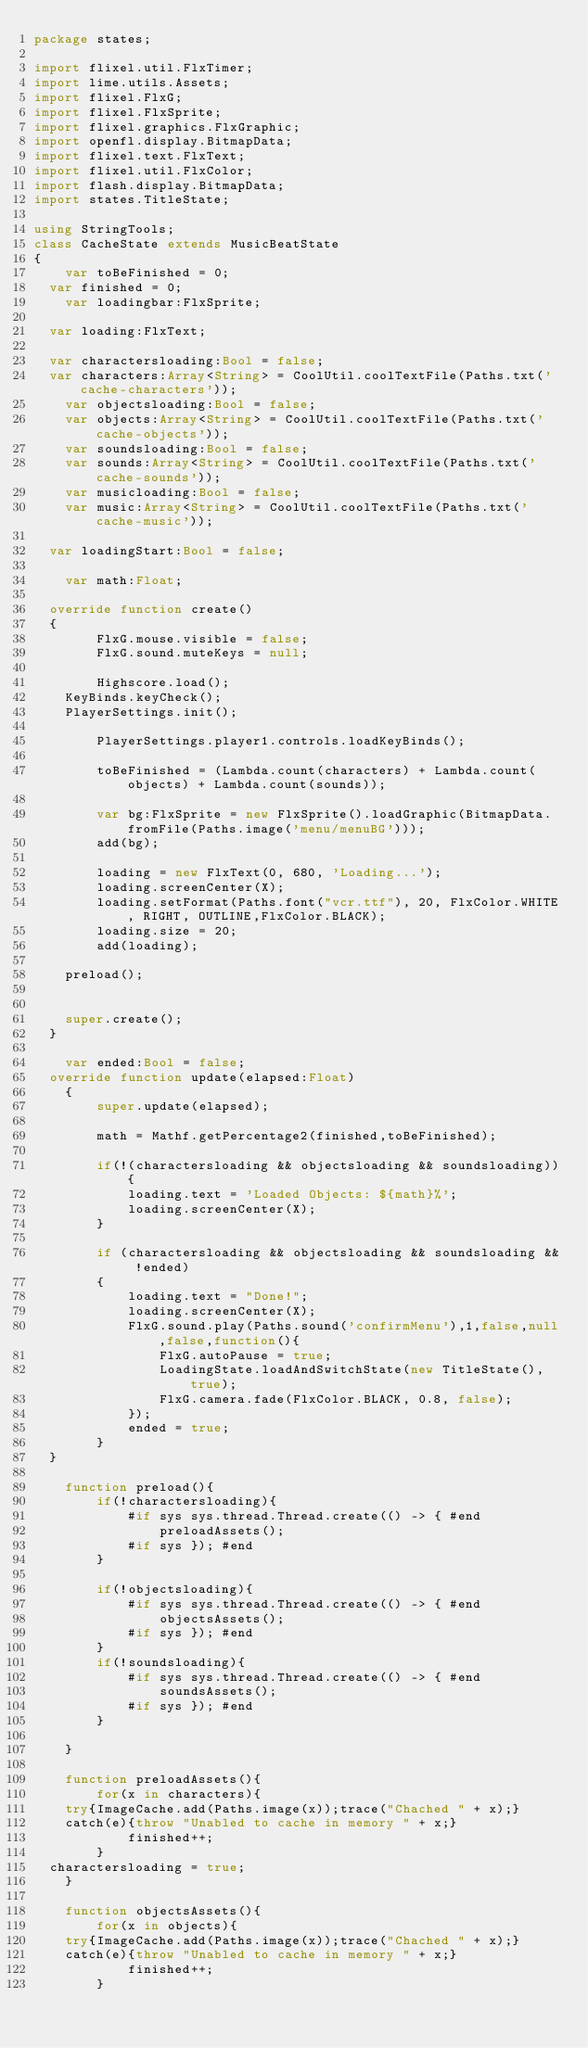<code> <loc_0><loc_0><loc_500><loc_500><_Haxe_>package states;

import flixel.util.FlxTimer;
import lime.utils.Assets;
import flixel.FlxG;
import flixel.FlxSprite;
import flixel.graphics.FlxGraphic;
import openfl.display.BitmapData;
import flixel.text.FlxText;
import flixel.util.FlxColor;
import flash.display.BitmapData;
import states.TitleState;

using StringTools;
class CacheState extends MusicBeatState
{
    var toBeFinished = 0;
	var finished = 0;
    var loadingbar:FlxSprite;

	var loading:FlxText;

	var charactersloading:Bool = false;
	var characters:Array<String> = CoolUtil.coolTextFile(Paths.txt('cache-characters'));
    var objectsloading:Bool = false;
    var objects:Array<String> = CoolUtil.coolTextFile(Paths.txt('cache-objects'));
    var soundsloading:Bool = false;
    var sounds:Array<String> = CoolUtil.coolTextFile(Paths.txt('cache-sounds'));
    var musicloading:Bool = false;
    var music:Array<String> = CoolUtil.coolTextFile(Paths.txt('cache-music'));

	var loadingStart:Bool = false;

    var math:Float;

	override function create()
	{
        FlxG.mouse.visible = false;
        FlxG.sound.muteKeys = null;

        Highscore.load();
		KeyBinds.keyCheck();
		PlayerSettings.init();

        PlayerSettings.player1.controls.loadKeyBinds();

        toBeFinished = (Lambda.count(characters) + Lambda.count(objects) + Lambda.count(sounds));

        var bg:FlxSprite = new FlxSprite().loadGraphic(BitmapData.fromFile(Paths.image('menu/menuBG')));
        add(bg);

        loading = new FlxText(0, 680, 'Loading...');
        loading.screenCenter(X);
        loading.setFormat(Paths.font("vcr.ttf"), 20, FlxColor.WHITE, RIGHT, OUTLINE,FlxColor.BLACK);
        loading.size = 20;
        add(loading);

		preload();
		

		super.create();
	}

    var ended:Bool = false;
	override function update(elapsed:Float)
    {
        super.update(elapsed);

        math = Mathf.getPercentage2(finished,toBeFinished);

        if(!(charactersloading && objectsloading && soundsloading)){
            loading.text = 'Loaded Objects: ${math}%';
            loading.screenCenter(X);
        }

        if (charactersloading && objectsloading && soundsloading && !ended)
        {
            loading.text = "Done!";
            loading.screenCenter(X);
            FlxG.sound.play(Paths.sound('confirmMenu'),1,false,null,false,function(){
                FlxG.autoPause = true;
                LoadingState.loadAndSwitchState(new TitleState(),true);
                FlxG.camera.fade(FlxColor.BLACK, 0.8, false);
            });
            ended = true;
        }
	}

    function preload(){
        if(!charactersloading){
            #if sys sys.thread.Thread.create(() -> { #end
                preloadAssets();
            #if sys }); #end
        }

        if(!objectsloading){
            #if sys sys.thread.Thread.create(() -> { #end
                objectsAssets();
            #if sys }); #end
        }
        if(!soundsloading){
            #if sys sys.thread.Thread.create(() -> { #end
                soundsAssets();
            #if sys }); #end
        }

    }

    function preloadAssets(){
        for(x in characters){
		try{ImageCache.add(Paths.image(x));trace("Chached " + x);}
		catch(e){throw "Unabled to cache in memory " + x;}
            finished++;
        }
	charactersloading = true;
    }

    function objectsAssets(){
        for(x in objects){
		try{ImageCache.add(Paths.image(x));trace("Chached " + x);}
		catch(e){throw "Unabled to cache in memory " + x;}
            finished++;
        }</code> 